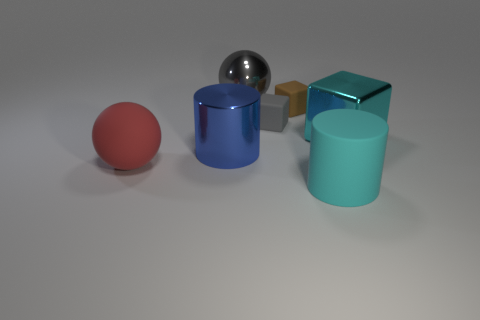How many objects are there in the image, and can you describe their colors? There are five objects in the image. Starting from the left, there's a small red sphere, a blue cylinder with a metallic sheen, a shiny silver sphere, a brown cube connected to a gold cube, and a larger cyan cylinder. 